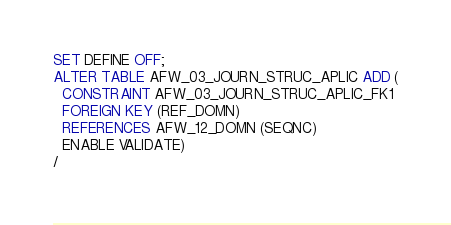Convert code to text. <code><loc_0><loc_0><loc_500><loc_500><_SQL_>SET DEFINE OFF;
ALTER TABLE AFW_03_JOURN_STRUC_APLIC ADD (
  CONSTRAINT AFW_03_JOURN_STRUC_APLIC_FK1 
  FOREIGN KEY (REF_DOMN) 
  REFERENCES AFW_12_DOMN (SEQNC)
  ENABLE VALIDATE)
/
</code> 